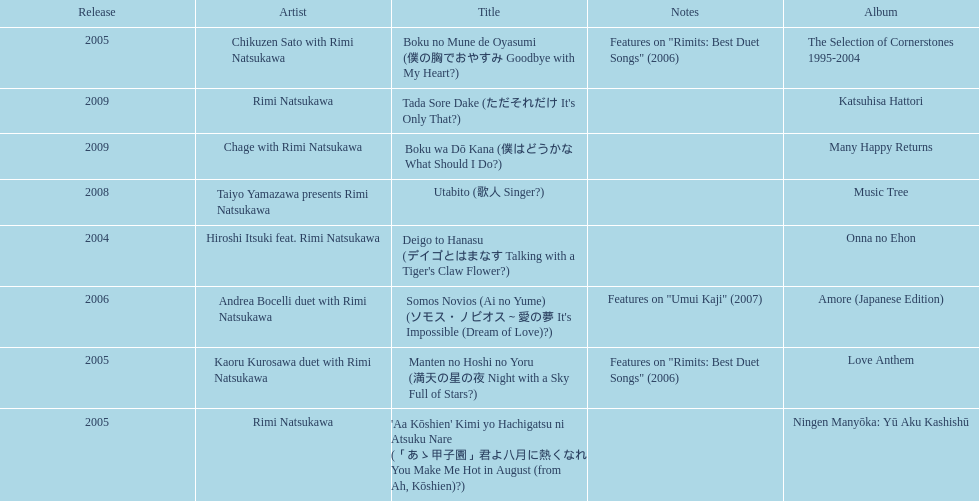How many other appearance did this artist make in 2005? 3. 